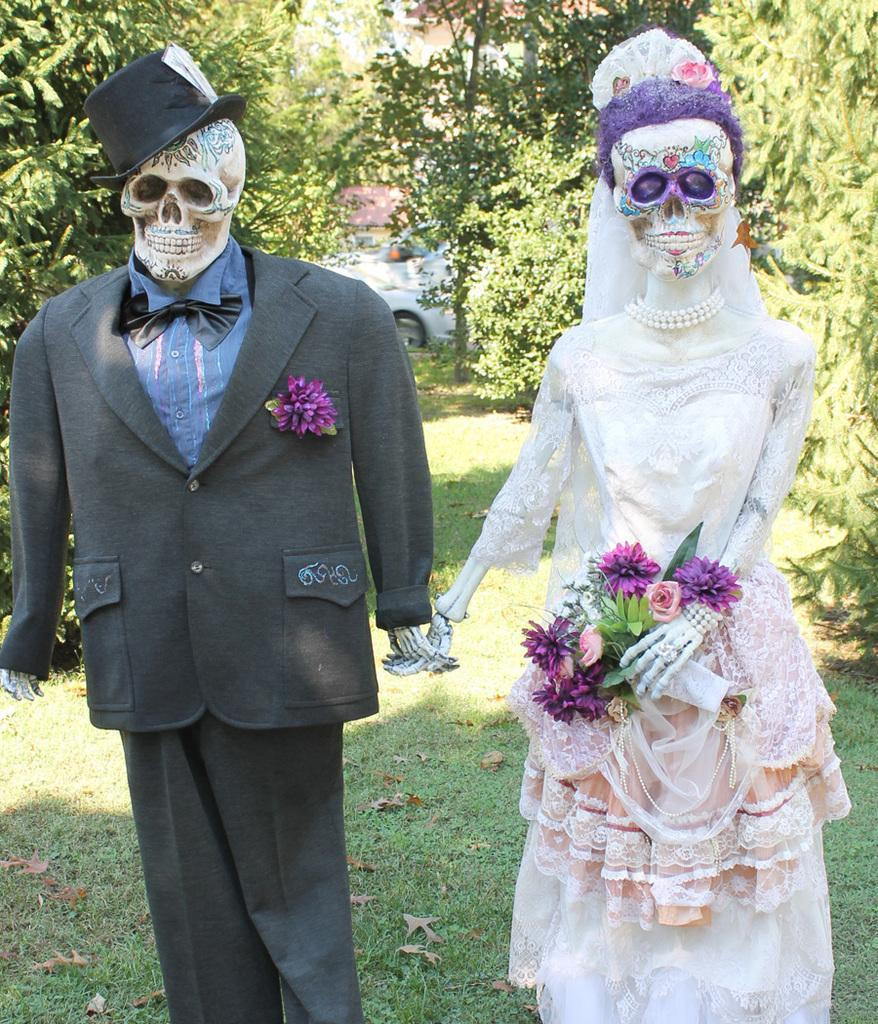What are the skeletons wearing in the image? There are clothes on the skeletons in the image. What type of flora can be seen in the image? There are flowers and a flower bouquet in the image. What type of headwear is present in the image? There is a veil and a hat in the image. What is the natural setting visible in the image? The background of the image includes grass and trees. What else can be seen in the background of the image? There is a vehicle in the background of the image. What decision was made by the boats in the morning in the image? There are no boats present in the image, and therefore no decision-making can be observed. 